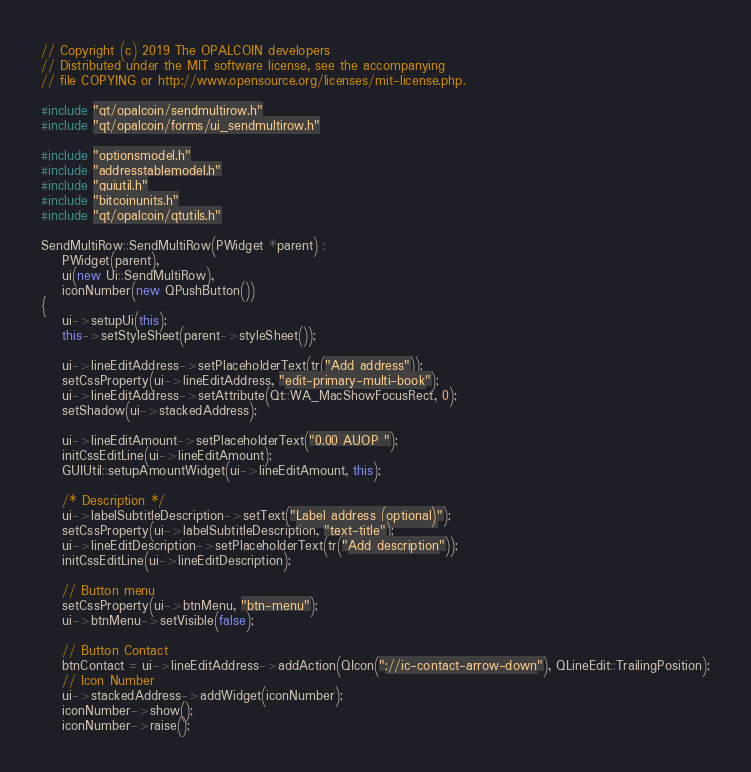<code> <loc_0><loc_0><loc_500><loc_500><_C++_>// Copyright (c) 2019 The OPALCOIN developers
// Distributed under the MIT software license, see the accompanying
// file COPYING or http://www.opensource.org/licenses/mit-license.php.

#include "qt/opalcoin/sendmultirow.h"
#include "qt/opalcoin/forms/ui_sendmultirow.h"

#include "optionsmodel.h"
#include "addresstablemodel.h"
#include "guiutil.h"
#include "bitcoinunits.h"
#include "qt/opalcoin/qtutils.h"

SendMultiRow::SendMultiRow(PWidget *parent) :
    PWidget(parent),
    ui(new Ui::SendMultiRow),
    iconNumber(new QPushButton())
{
    ui->setupUi(this);
    this->setStyleSheet(parent->styleSheet());

    ui->lineEditAddress->setPlaceholderText(tr("Add address"));
    setCssProperty(ui->lineEditAddress, "edit-primary-multi-book");
    ui->lineEditAddress->setAttribute(Qt::WA_MacShowFocusRect, 0);
    setShadow(ui->stackedAddress);

    ui->lineEditAmount->setPlaceholderText("0.00 AUOP ");
    initCssEditLine(ui->lineEditAmount);
    GUIUtil::setupAmountWidget(ui->lineEditAmount, this);

    /* Description */
    ui->labelSubtitleDescription->setText("Label address (optional)");
    setCssProperty(ui->labelSubtitleDescription, "text-title");
    ui->lineEditDescription->setPlaceholderText(tr("Add description"));
    initCssEditLine(ui->lineEditDescription);

    // Button menu
    setCssProperty(ui->btnMenu, "btn-menu");
    ui->btnMenu->setVisible(false);

    // Button Contact
    btnContact = ui->lineEditAddress->addAction(QIcon("://ic-contact-arrow-down"), QLineEdit::TrailingPosition);
    // Icon Number
    ui->stackedAddress->addWidget(iconNumber);
    iconNumber->show();
    iconNumber->raise();
</code> 